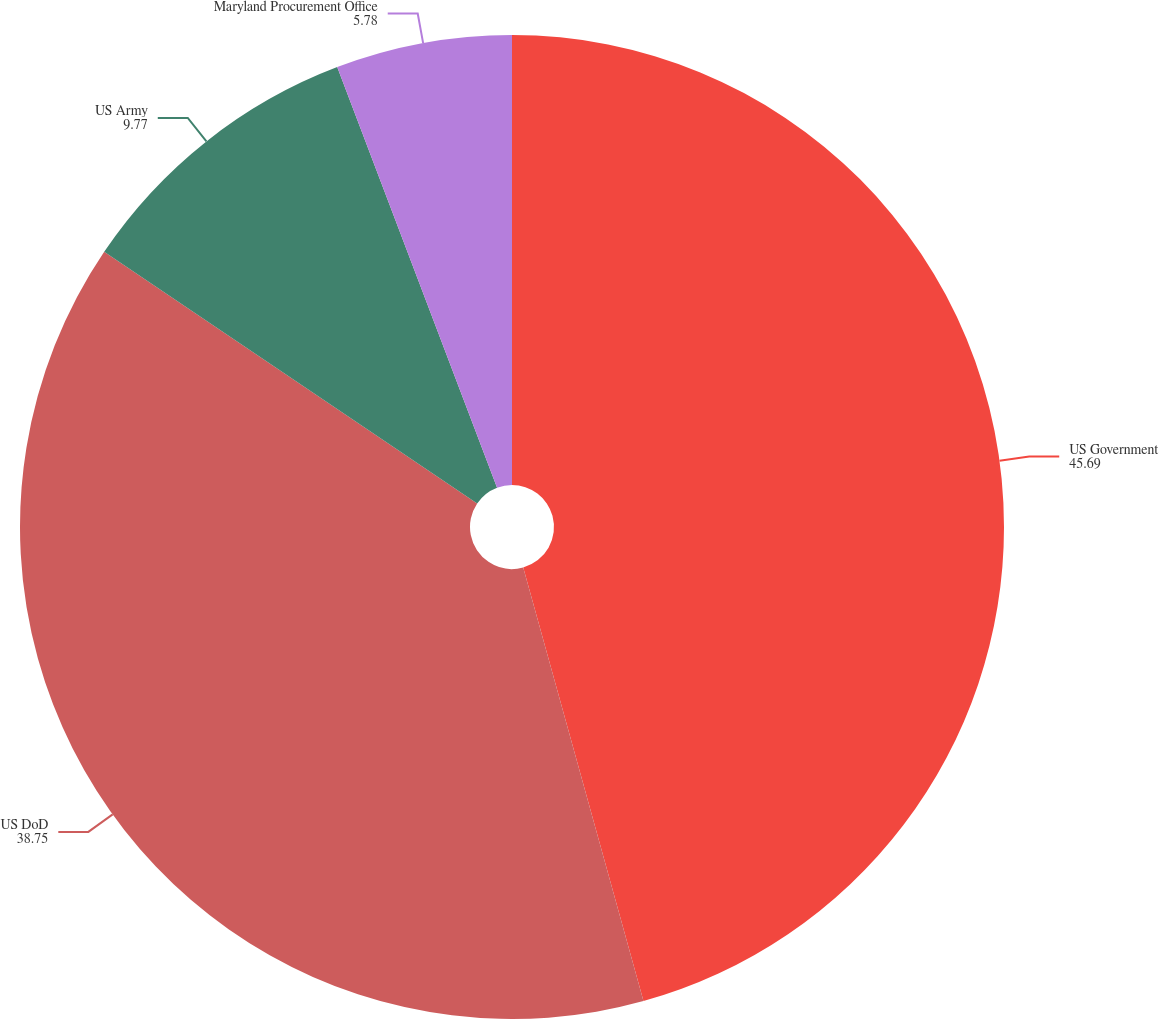Convert chart to OTSL. <chart><loc_0><loc_0><loc_500><loc_500><pie_chart><fcel>US Government<fcel>US DoD<fcel>US Army<fcel>Maryland Procurement Office<nl><fcel>45.69%<fcel>38.75%<fcel>9.77%<fcel>5.78%<nl></chart> 